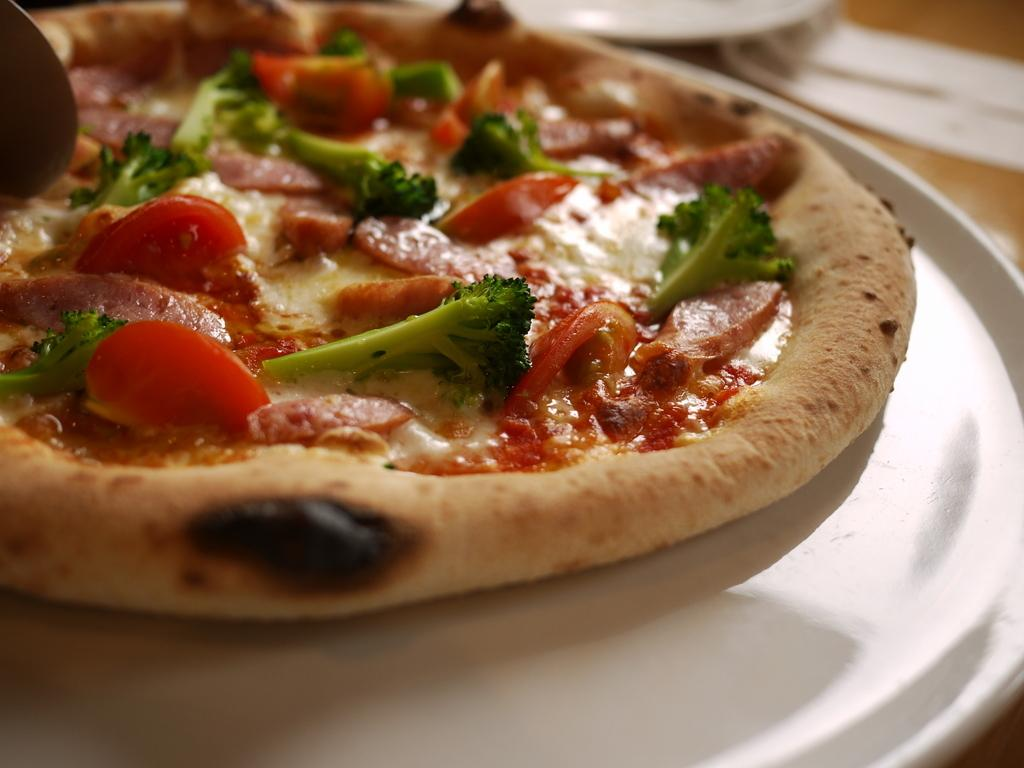What type of food is visible in the image? There is a pizza in the image. How is the pizza presented in the image? The pizza is on a white platter. What can be seen on the wooden surface in the image? There is a white object on a wooden surface in the image. What degree does the bottle have in the image? There is no bottle present in the image, so the concept of a degree does not apply. 